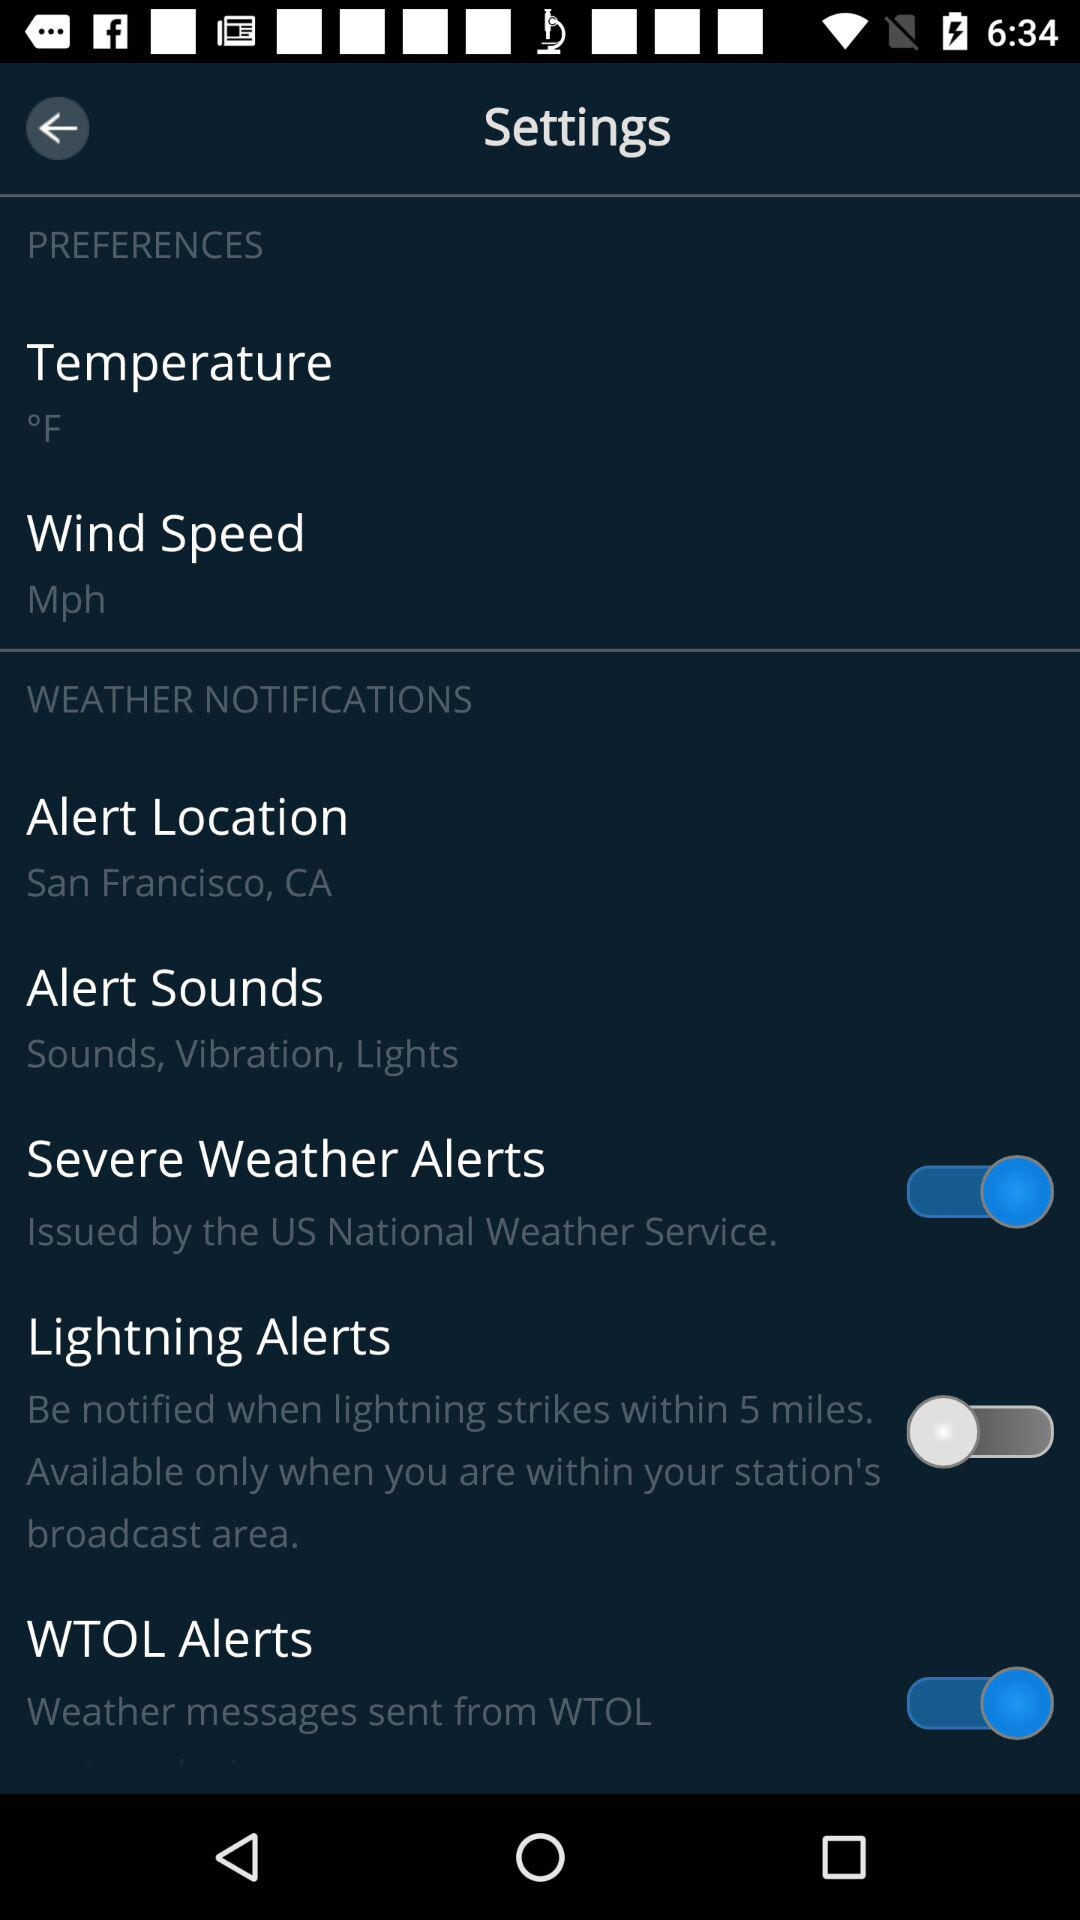Which alert option has been enabled? The enabled alert options are "Severe Weather Alerts" and "WTOL Alerts". 